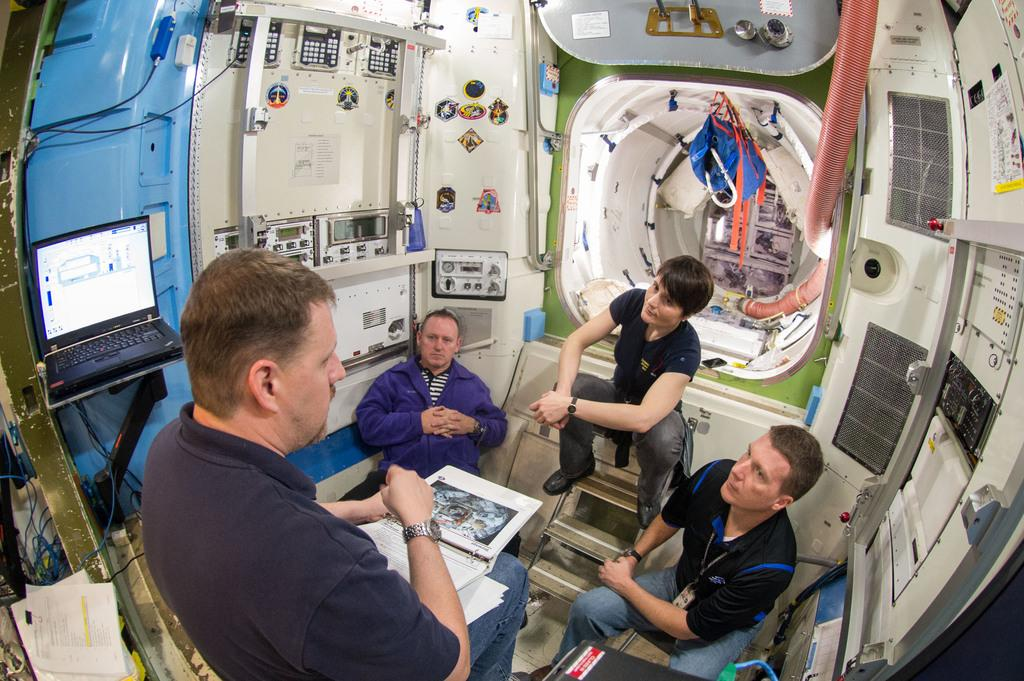What are the people in the image doing? The people in the image are sitting. What can be seen in the background of the image? There are objects visible in the background of the image. What is located on the left side of the image? There is a laptop and papers on the left side of the image. What team is the person in the image supporting? There is no indication of a team or any sports-related activity in the image. 